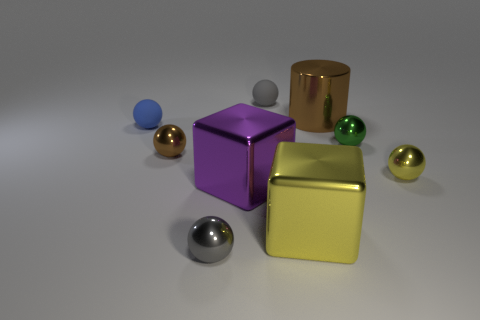What textures are present in the image? The textures in the image are predominantly smooth and shiny, as seen on the metal and glass-like surfaces of the blocks and spheres. The background surface has a matte finish with a slightly grainy texture, providing a contrast to the polished objects. If these objects were part of a larger scene, what could it be? If these objects were part of a larger scene, they might belong in a modern art installation, a designer's concept for a futuristic space, or a visual representation in a physics experiment demonstrating materials and light properties. 